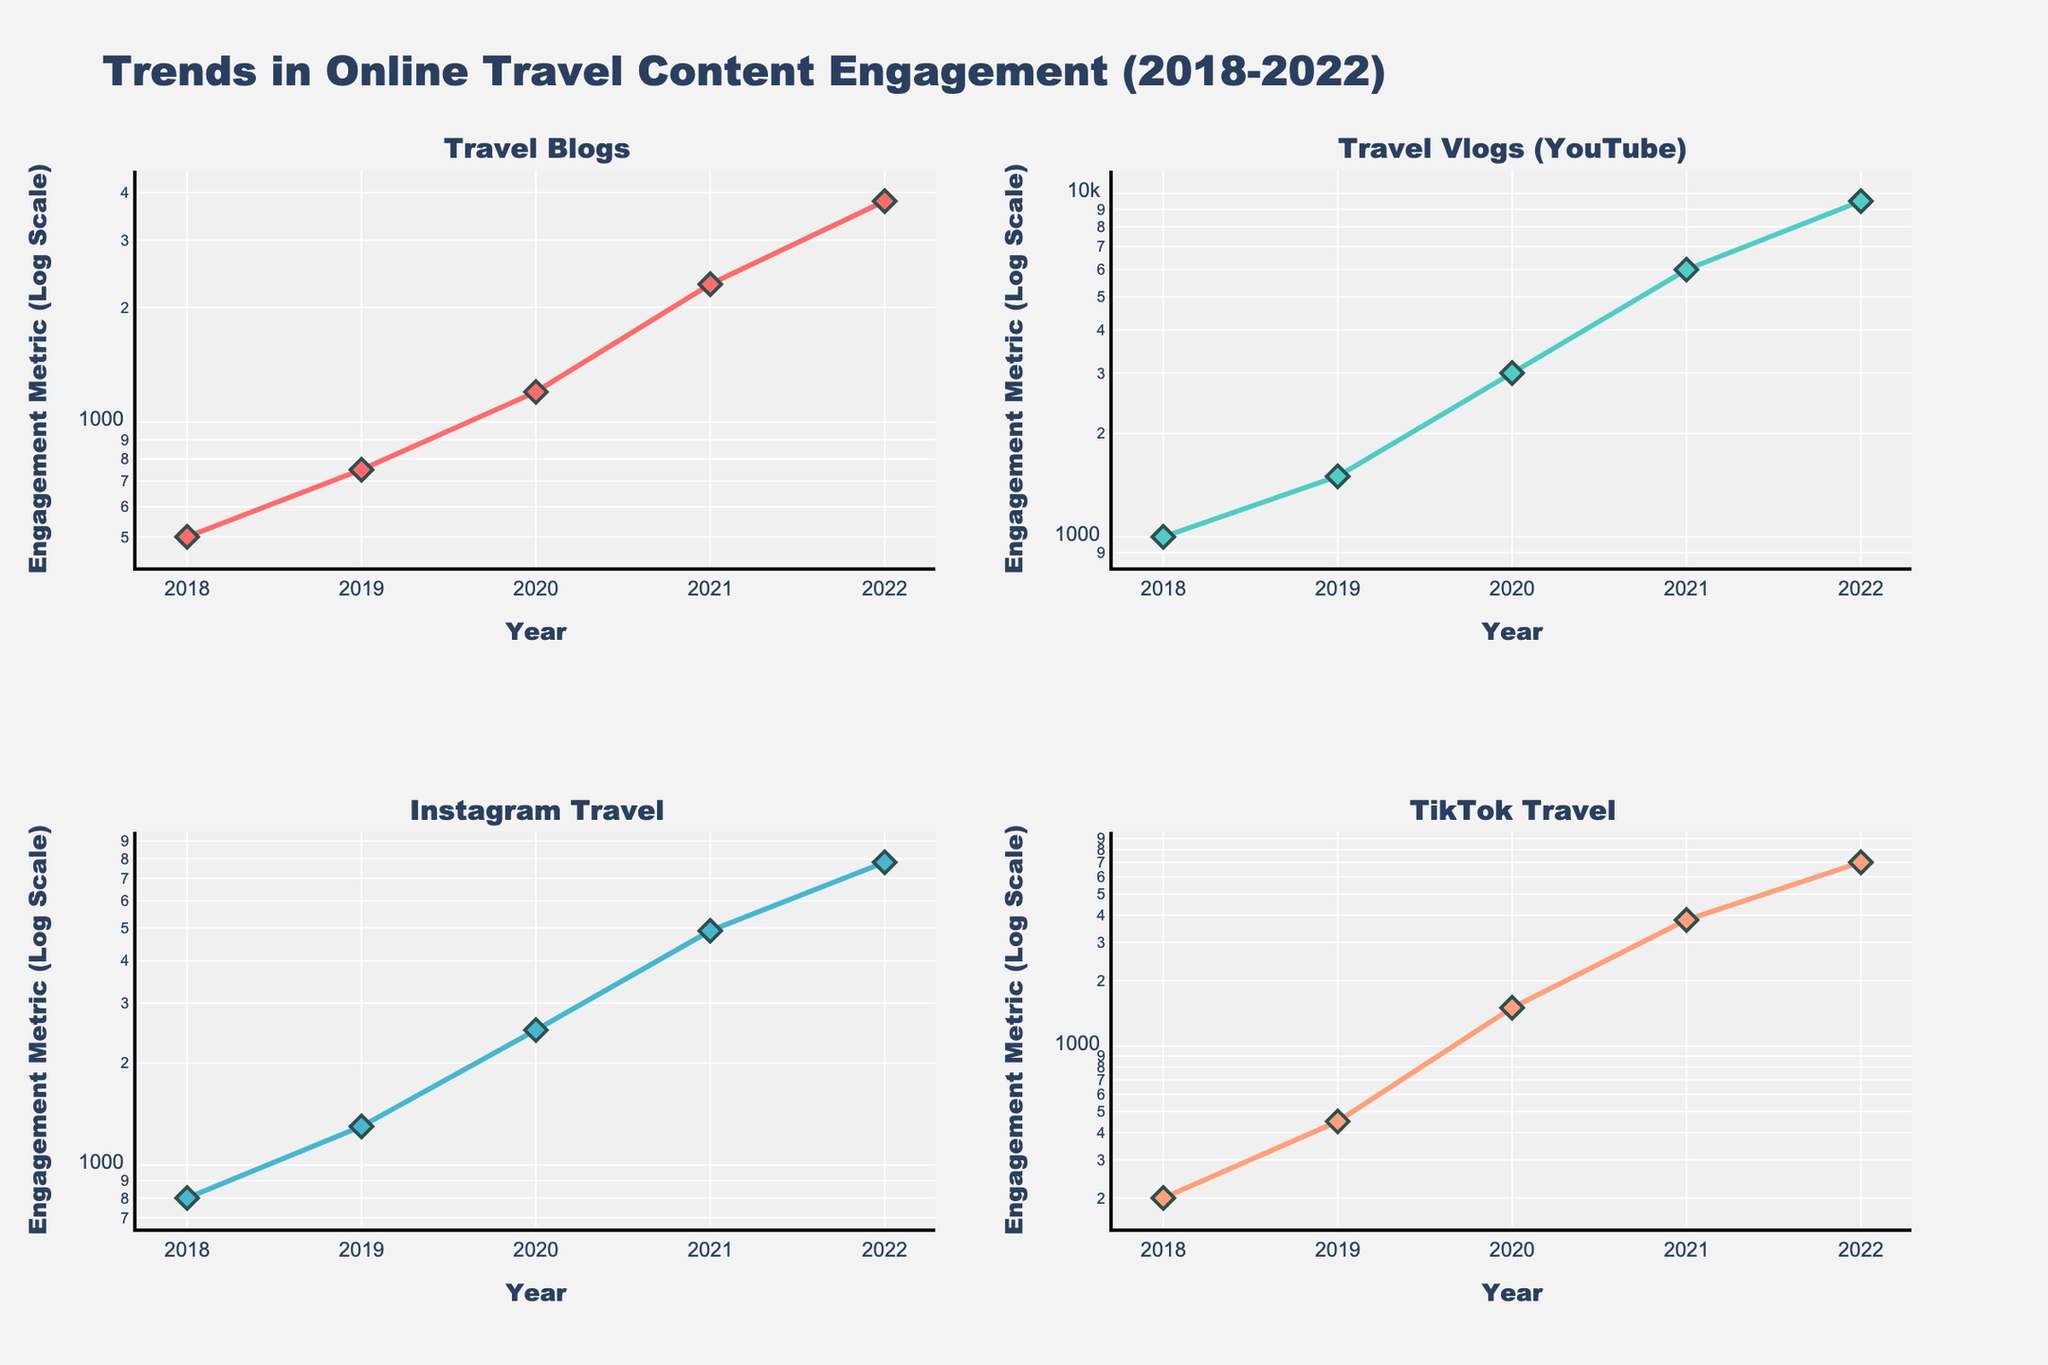What is the overall title of the figure? The overall title of the figure is displayed at the top and is the main heading that describes what is being shown in the figure. The title is "Trends in Online Travel Content Engagement (2018-2022)".
Answer: Trends in Online Travel Content Engagement (2018-2022) What are the four platforms shown in the figure? Each subplot in the figure represents one platform, and the titles of the subplots indicate which platform is being shown. The platforms are "Travel Blogs", "Travel Vlogs (YouTube)", "Instagram Travel", and "TikTok Travel".
Answer: Travel Blogs, Travel Vlogs (YouTube), Instagram Travel, TikTok Travel Which platform had the highest engagement metric in 2022? By looking at the y-axis values in 2022 for each subplot, we can compare the engagement metrics of the platforms. The "Travel Vlogs (YouTube)" subplot shows the highest value, reaching up to 9500.
Answer: Travel Vlogs (YouTube) How did the engagement metric for TikTok Travel change from 2018 to 2022? To understand the change, we compare the engagement metric in 2018 (200) with that in 2022 (7000) for TikTok Travel, as shown in the subplot. The change can be calculated as 7000 - 200.
Answer: Increased by 6800 Which platform experienced the greatest relative increase in engagement from 2018 to 2022? To determine the greatest relative increase, we need to calculate the relative increase for each platform. This is done by (Value in 2022 - Value in 2018) / Value in 2018. "TikTok Travel" increased from 200 to 7000, resulting in a relative increase of (7000 - 200) / 200 = 34.
Answer: TikTok Travel In which year did Travel Blogs see the biggest jump in engagement metric? By observing the year-to-year differences in the "Travel Blogs" subplot, we notice the largest jump occurred between 2020 (1200) and 2021 (2300), with a difference of 2300 - 1200 = 1100.
Answer: Between 2020 and 2021 Compare the engagement metrics for Instagram Travel and TikTok Travel in 2020. Which one was higher and by how much? Locating the 2020 values in the respective subplots shows Instagram Travel at 2500 and TikTok Travel at 1500. The difference is 2500 - 1500.
Answer: Instagram Travel by 1000 What kind of scale is used for the y-axes in the subplots? The y-axes of all subplots are labeled with labels indicating exponential or log-based values, thereby signaling the use of a log scale, which helps in better visualizing data with large ranges.
Answer: Logarithmic scale Which platform showed a linear trend in engagement metrics on the log scale from 2018 to 2022? By examining the lines in the log-scaled subplots, TikTok Travel shows a more straight and consistent upward trend, indicating a linear trend on the log scale.
Answer: TikTok Travel How many data points are plotted for each platform? Counting the markers for each line in any subplot reveals there are 5 data points, corresponding to the years from 2018 to 2022.
Answer: 5 